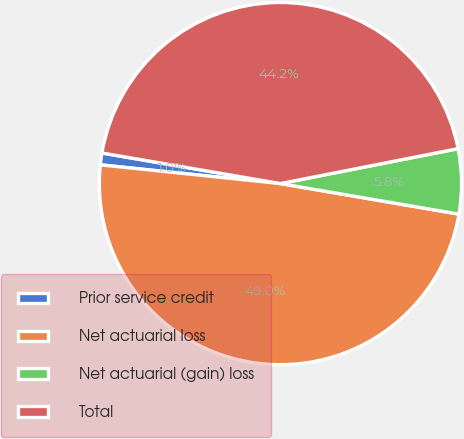Convert chart to OTSL. <chart><loc_0><loc_0><loc_500><loc_500><pie_chart><fcel>Prior service credit<fcel>Net actuarial loss<fcel>Net actuarial (gain) loss<fcel>Total<nl><fcel>1.05%<fcel>48.95%<fcel>5.79%<fcel>44.21%<nl></chart> 